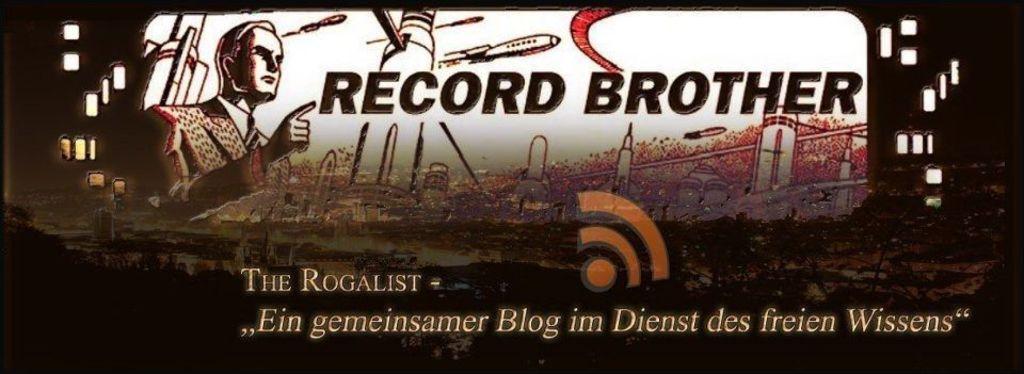What is the ad for?
Make the answer very short. Record brother. 